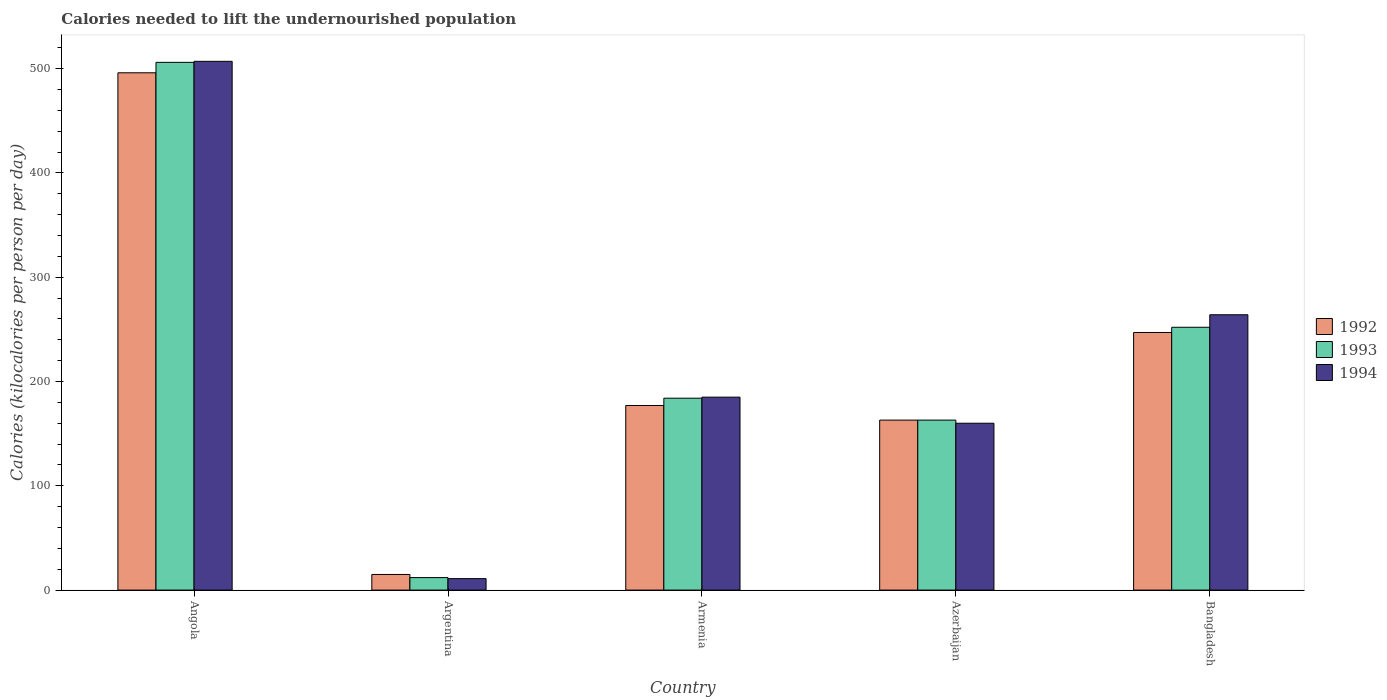How many different coloured bars are there?
Make the answer very short. 3. How many groups of bars are there?
Keep it short and to the point. 5. Are the number of bars per tick equal to the number of legend labels?
Your answer should be very brief. Yes. What is the label of the 1st group of bars from the left?
Make the answer very short. Angola. What is the total calories needed to lift the undernourished population in 1992 in Armenia?
Provide a short and direct response. 177. Across all countries, what is the maximum total calories needed to lift the undernourished population in 1992?
Provide a succinct answer. 496. In which country was the total calories needed to lift the undernourished population in 1992 maximum?
Provide a succinct answer. Angola. What is the total total calories needed to lift the undernourished population in 1994 in the graph?
Your answer should be compact. 1127. What is the difference between the total calories needed to lift the undernourished population in 1994 in Angola and that in Azerbaijan?
Give a very brief answer. 347. What is the difference between the total calories needed to lift the undernourished population in 1992 in Argentina and the total calories needed to lift the undernourished population in 1993 in Azerbaijan?
Your answer should be very brief. -148. What is the average total calories needed to lift the undernourished population in 1992 per country?
Your response must be concise. 219.6. In how many countries, is the total calories needed to lift the undernourished population in 1993 greater than 180 kilocalories?
Keep it short and to the point. 3. What is the ratio of the total calories needed to lift the undernourished population in 1993 in Armenia to that in Azerbaijan?
Make the answer very short. 1.13. What is the difference between the highest and the second highest total calories needed to lift the undernourished population in 1993?
Your answer should be compact. -322. What is the difference between the highest and the lowest total calories needed to lift the undernourished population in 1993?
Make the answer very short. 494. In how many countries, is the total calories needed to lift the undernourished population in 1994 greater than the average total calories needed to lift the undernourished population in 1994 taken over all countries?
Your response must be concise. 2. Is the sum of the total calories needed to lift the undernourished population in 1994 in Argentina and Azerbaijan greater than the maximum total calories needed to lift the undernourished population in 1993 across all countries?
Your answer should be compact. No. Is it the case that in every country, the sum of the total calories needed to lift the undernourished population in 1994 and total calories needed to lift the undernourished population in 1992 is greater than the total calories needed to lift the undernourished population in 1993?
Your answer should be very brief. Yes. How many countries are there in the graph?
Provide a succinct answer. 5. What is the difference between two consecutive major ticks on the Y-axis?
Your answer should be very brief. 100. Are the values on the major ticks of Y-axis written in scientific E-notation?
Your answer should be very brief. No. Does the graph contain any zero values?
Keep it short and to the point. No. Does the graph contain grids?
Offer a very short reply. No. Where does the legend appear in the graph?
Provide a succinct answer. Center right. What is the title of the graph?
Give a very brief answer. Calories needed to lift the undernourished population. Does "2014" appear as one of the legend labels in the graph?
Your answer should be compact. No. What is the label or title of the Y-axis?
Give a very brief answer. Calories (kilocalories per person per day). What is the Calories (kilocalories per person per day) of 1992 in Angola?
Ensure brevity in your answer.  496. What is the Calories (kilocalories per person per day) in 1993 in Angola?
Provide a succinct answer. 506. What is the Calories (kilocalories per person per day) in 1994 in Angola?
Your response must be concise. 507. What is the Calories (kilocalories per person per day) of 1992 in Argentina?
Make the answer very short. 15. What is the Calories (kilocalories per person per day) in 1992 in Armenia?
Your answer should be compact. 177. What is the Calories (kilocalories per person per day) of 1993 in Armenia?
Your answer should be compact. 184. What is the Calories (kilocalories per person per day) of 1994 in Armenia?
Make the answer very short. 185. What is the Calories (kilocalories per person per day) of 1992 in Azerbaijan?
Ensure brevity in your answer.  163. What is the Calories (kilocalories per person per day) in 1993 in Azerbaijan?
Your answer should be very brief. 163. What is the Calories (kilocalories per person per day) of 1994 in Azerbaijan?
Offer a very short reply. 160. What is the Calories (kilocalories per person per day) in 1992 in Bangladesh?
Your response must be concise. 247. What is the Calories (kilocalories per person per day) of 1993 in Bangladesh?
Offer a terse response. 252. What is the Calories (kilocalories per person per day) of 1994 in Bangladesh?
Ensure brevity in your answer.  264. Across all countries, what is the maximum Calories (kilocalories per person per day) in 1992?
Give a very brief answer. 496. Across all countries, what is the maximum Calories (kilocalories per person per day) of 1993?
Keep it short and to the point. 506. Across all countries, what is the maximum Calories (kilocalories per person per day) in 1994?
Offer a terse response. 507. What is the total Calories (kilocalories per person per day) of 1992 in the graph?
Provide a short and direct response. 1098. What is the total Calories (kilocalories per person per day) in 1993 in the graph?
Offer a terse response. 1117. What is the total Calories (kilocalories per person per day) in 1994 in the graph?
Your answer should be very brief. 1127. What is the difference between the Calories (kilocalories per person per day) of 1992 in Angola and that in Argentina?
Your answer should be compact. 481. What is the difference between the Calories (kilocalories per person per day) of 1993 in Angola and that in Argentina?
Ensure brevity in your answer.  494. What is the difference between the Calories (kilocalories per person per day) of 1994 in Angola and that in Argentina?
Your answer should be compact. 496. What is the difference between the Calories (kilocalories per person per day) in 1992 in Angola and that in Armenia?
Offer a very short reply. 319. What is the difference between the Calories (kilocalories per person per day) in 1993 in Angola and that in Armenia?
Ensure brevity in your answer.  322. What is the difference between the Calories (kilocalories per person per day) of 1994 in Angola and that in Armenia?
Give a very brief answer. 322. What is the difference between the Calories (kilocalories per person per day) in 1992 in Angola and that in Azerbaijan?
Make the answer very short. 333. What is the difference between the Calories (kilocalories per person per day) in 1993 in Angola and that in Azerbaijan?
Ensure brevity in your answer.  343. What is the difference between the Calories (kilocalories per person per day) in 1994 in Angola and that in Azerbaijan?
Your answer should be compact. 347. What is the difference between the Calories (kilocalories per person per day) in 1992 in Angola and that in Bangladesh?
Your answer should be compact. 249. What is the difference between the Calories (kilocalories per person per day) of 1993 in Angola and that in Bangladesh?
Offer a terse response. 254. What is the difference between the Calories (kilocalories per person per day) of 1994 in Angola and that in Bangladesh?
Give a very brief answer. 243. What is the difference between the Calories (kilocalories per person per day) in 1992 in Argentina and that in Armenia?
Your answer should be very brief. -162. What is the difference between the Calories (kilocalories per person per day) in 1993 in Argentina and that in Armenia?
Ensure brevity in your answer.  -172. What is the difference between the Calories (kilocalories per person per day) of 1994 in Argentina and that in Armenia?
Provide a succinct answer. -174. What is the difference between the Calories (kilocalories per person per day) in 1992 in Argentina and that in Azerbaijan?
Provide a succinct answer. -148. What is the difference between the Calories (kilocalories per person per day) in 1993 in Argentina and that in Azerbaijan?
Your answer should be very brief. -151. What is the difference between the Calories (kilocalories per person per day) of 1994 in Argentina and that in Azerbaijan?
Give a very brief answer. -149. What is the difference between the Calories (kilocalories per person per day) of 1992 in Argentina and that in Bangladesh?
Make the answer very short. -232. What is the difference between the Calories (kilocalories per person per day) in 1993 in Argentina and that in Bangladesh?
Ensure brevity in your answer.  -240. What is the difference between the Calories (kilocalories per person per day) in 1994 in Argentina and that in Bangladesh?
Offer a terse response. -253. What is the difference between the Calories (kilocalories per person per day) in 1992 in Armenia and that in Azerbaijan?
Your response must be concise. 14. What is the difference between the Calories (kilocalories per person per day) of 1992 in Armenia and that in Bangladesh?
Keep it short and to the point. -70. What is the difference between the Calories (kilocalories per person per day) in 1993 in Armenia and that in Bangladesh?
Make the answer very short. -68. What is the difference between the Calories (kilocalories per person per day) in 1994 in Armenia and that in Bangladesh?
Your answer should be compact. -79. What is the difference between the Calories (kilocalories per person per day) in 1992 in Azerbaijan and that in Bangladesh?
Make the answer very short. -84. What is the difference between the Calories (kilocalories per person per day) in 1993 in Azerbaijan and that in Bangladesh?
Your answer should be very brief. -89. What is the difference between the Calories (kilocalories per person per day) of 1994 in Azerbaijan and that in Bangladesh?
Your answer should be very brief. -104. What is the difference between the Calories (kilocalories per person per day) of 1992 in Angola and the Calories (kilocalories per person per day) of 1993 in Argentina?
Make the answer very short. 484. What is the difference between the Calories (kilocalories per person per day) in 1992 in Angola and the Calories (kilocalories per person per day) in 1994 in Argentina?
Your answer should be very brief. 485. What is the difference between the Calories (kilocalories per person per day) of 1993 in Angola and the Calories (kilocalories per person per day) of 1994 in Argentina?
Provide a succinct answer. 495. What is the difference between the Calories (kilocalories per person per day) in 1992 in Angola and the Calories (kilocalories per person per day) in 1993 in Armenia?
Make the answer very short. 312. What is the difference between the Calories (kilocalories per person per day) in 1992 in Angola and the Calories (kilocalories per person per day) in 1994 in Armenia?
Offer a terse response. 311. What is the difference between the Calories (kilocalories per person per day) of 1993 in Angola and the Calories (kilocalories per person per day) of 1994 in Armenia?
Provide a short and direct response. 321. What is the difference between the Calories (kilocalories per person per day) in 1992 in Angola and the Calories (kilocalories per person per day) in 1993 in Azerbaijan?
Offer a very short reply. 333. What is the difference between the Calories (kilocalories per person per day) of 1992 in Angola and the Calories (kilocalories per person per day) of 1994 in Azerbaijan?
Give a very brief answer. 336. What is the difference between the Calories (kilocalories per person per day) of 1993 in Angola and the Calories (kilocalories per person per day) of 1994 in Azerbaijan?
Keep it short and to the point. 346. What is the difference between the Calories (kilocalories per person per day) in 1992 in Angola and the Calories (kilocalories per person per day) in 1993 in Bangladesh?
Offer a very short reply. 244. What is the difference between the Calories (kilocalories per person per day) in 1992 in Angola and the Calories (kilocalories per person per day) in 1994 in Bangladesh?
Provide a succinct answer. 232. What is the difference between the Calories (kilocalories per person per day) of 1993 in Angola and the Calories (kilocalories per person per day) of 1994 in Bangladesh?
Make the answer very short. 242. What is the difference between the Calories (kilocalories per person per day) of 1992 in Argentina and the Calories (kilocalories per person per day) of 1993 in Armenia?
Provide a succinct answer. -169. What is the difference between the Calories (kilocalories per person per day) of 1992 in Argentina and the Calories (kilocalories per person per day) of 1994 in Armenia?
Offer a very short reply. -170. What is the difference between the Calories (kilocalories per person per day) of 1993 in Argentina and the Calories (kilocalories per person per day) of 1994 in Armenia?
Your answer should be very brief. -173. What is the difference between the Calories (kilocalories per person per day) in 1992 in Argentina and the Calories (kilocalories per person per day) in 1993 in Azerbaijan?
Your answer should be very brief. -148. What is the difference between the Calories (kilocalories per person per day) of 1992 in Argentina and the Calories (kilocalories per person per day) of 1994 in Azerbaijan?
Ensure brevity in your answer.  -145. What is the difference between the Calories (kilocalories per person per day) of 1993 in Argentina and the Calories (kilocalories per person per day) of 1994 in Azerbaijan?
Your answer should be compact. -148. What is the difference between the Calories (kilocalories per person per day) in 1992 in Argentina and the Calories (kilocalories per person per day) in 1993 in Bangladesh?
Make the answer very short. -237. What is the difference between the Calories (kilocalories per person per day) of 1992 in Argentina and the Calories (kilocalories per person per day) of 1994 in Bangladesh?
Ensure brevity in your answer.  -249. What is the difference between the Calories (kilocalories per person per day) in 1993 in Argentina and the Calories (kilocalories per person per day) in 1994 in Bangladesh?
Keep it short and to the point. -252. What is the difference between the Calories (kilocalories per person per day) in 1992 in Armenia and the Calories (kilocalories per person per day) in 1993 in Bangladesh?
Make the answer very short. -75. What is the difference between the Calories (kilocalories per person per day) in 1992 in Armenia and the Calories (kilocalories per person per day) in 1994 in Bangladesh?
Offer a very short reply. -87. What is the difference between the Calories (kilocalories per person per day) of 1993 in Armenia and the Calories (kilocalories per person per day) of 1994 in Bangladesh?
Give a very brief answer. -80. What is the difference between the Calories (kilocalories per person per day) of 1992 in Azerbaijan and the Calories (kilocalories per person per day) of 1993 in Bangladesh?
Your answer should be compact. -89. What is the difference between the Calories (kilocalories per person per day) of 1992 in Azerbaijan and the Calories (kilocalories per person per day) of 1994 in Bangladesh?
Ensure brevity in your answer.  -101. What is the difference between the Calories (kilocalories per person per day) in 1993 in Azerbaijan and the Calories (kilocalories per person per day) in 1994 in Bangladesh?
Your answer should be very brief. -101. What is the average Calories (kilocalories per person per day) of 1992 per country?
Make the answer very short. 219.6. What is the average Calories (kilocalories per person per day) in 1993 per country?
Give a very brief answer. 223.4. What is the average Calories (kilocalories per person per day) in 1994 per country?
Your answer should be compact. 225.4. What is the difference between the Calories (kilocalories per person per day) in 1992 and Calories (kilocalories per person per day) in 1994 in Argentina?
Ensure brevity in your answer.  4. What is the difference between the Calories (kilocalories per person per day) in 1992 and Calories (kilocalories per person per day) in 1993 in Armenia?
Your answer should be compact. -7. What is the difference between the Calories (kilocalories per person per day) of 1992 and Calories (kilocalories per person per day) of 1994 in Armenia?
Ensure brevity in your answer.  -8. What is the difference between the Calories (kilocalories per person per day) in 1993 and Calories (kilocalories per person per day) in 1994 in Armenia?
Provide a succinct answer. -1. What is the difference between the Calories (kilocalories per person per day) of 1993 and Calories (kilocalories per person per day) of 1994 in Azerbaijan?
Offer a very short reply. 3. What is the ratio of the Calories (kilocalories per person per day) in 1992 in Angola to that in Argentina?
Your response must be concise. 33.07. What is the ratio of the Calories (kilocalories per person per day) in 1993 in Angola to that in Argentina?
Provide a succinct answer. 42.17. What is the ratio of the Calories (kilocalories per person per day) of 1994 in Angola to that in Argentina?
Your answer should be very brief. 46.09. What is the ratio of the Calories (kilocalories per person per day) of 1992 in Angola to that in Armenia?
Offer a very short reply. 2.8. What is the ratio of the Calories (kilocalories per person per day) of 1993 in Angola to that in Armenia?
Offer a very short reply. 2.75. What is the ratio of the Calories (kilocalories per person per day) of 1994 in Angola to that in Armenia?
Offer a terse response. 2.74. What is the ratio of the Calories (kilocalories per person per day) of 1992 in Angola to that in Azerbaijan?
Ensure brevity in your answer.  3.04. What is the ratio of the Calories (kilocalories per person per day) in 1993 in Angola to that in Azerbaijan?
Offer a very short reply. 3.1. What is the ratio of the Calories (kilocalories per person per day) in 1994 in Angola to that in Azerbaijan?
Ensure brevity in your answer.  3.17. What is the ratio of the Calories (kilocalories per person per day) of 1992 in Angola to that in Bangladesh?
Make the answer very short. 2.01. What is the ratio of the Calories (kilocalories per person per day) of 1993 in Angola to that in Bangladesh?
Keep it short and to the point. 2.01. What is the ratio of the Calories (kilocalories per person per day) in 1994 in Angola to that in Bangladesh?
Your response must be concise. 1.92. What is the ratio of the Calories (kilocalories per person per day) of 1992 in Argentina to that in Armenia?
Give a very brief answer. 0.08. What is the ratio of the Calories (kilocalories per person per day) in 1993 in Argentina to that in Armenia?
Your response must be concise. 0.07. What is the ratio of the Calories (kilocalories per person per day) in 1994 in Argentina to that in Armenia?
Offer a terse response. 0.06. What is the ratio of the Calories (kilocalories per person per day) of 1992 in Argentina to that in Azerbaijan?
Ensure brevity in your answer.  0.09. What is the ratio of the Calories (kilocalories per person per day) of 1993 in Argentina to that in Azerbaijan?
Keep it short and to the point. 0.07. What is the ratio of the Calories (kilocalories per person per day) of 1994 in Argentina to that in Azerbaijan?
Keep it short and to the point. 0.07. What is the ratio of the Calories (kilocalories per person per day) in 1992 in Argentina to that in Bangladesh?
Ensure brevity in your answer.  0.06. What is the ratio of the Calories (kilocalories per person per day) of 1993 in Argentina to that in Bangladesh?
Your answer should be very brief. 0.05. What is the ratio of the Calories (kilocalories per person per day) of 1994 in Argentina to that in Bangladesh?
Provide a succinct answer. 0.04. What is the ratio of the Calories (kilocalories per person per day) of 1992 in Armenia to that in Azerbaijan?
Ensure brevity in your answer.  1.09. What is the ratio of the Calories (kilocalories per person per day) of 1993 in Armenia to that in Azerbaijan?
Offer a terse response. 1.13. What is the ratio of the Calories (kilocalories per person per day) of 1994 in Armenia to that in Azerbaijan?
Make the answer very short. 1.16. What is the ratio of the Calories (kilocalories per person per day) in 1992 in Armenia to that in Bangladesh?
Keep it short and to the point. 0.72. What is the ratio of the Calories (kilocalories per person per day) of 1993 in Armenia to that in Bangladesh?
Keep it short and to the point. 0.73. What is the ratio of the Calories (kilocalories per person per day) of 1994 in Armenia to that in Bangladesh?
Provide a short and direct response. 0.7. What is the ratio of the Calories (kilocalories per person per day) in 1992 in Azerbaijan to that in Bangladesh?
Your answer should be very brief. 0.66. What is the ratio of the Calories (kilocalories per person per day) of 1993 in Azerbaijan to that in Bangladesh?
Your response must be concise. 0.65. What is the ratio of the Calories (kilocalories per person per day) in 1994 in Azerbaijan to that in Bangladesh?
Give a very brief answer. 0.61. What is the difference between the highest and the second highest Calories (kilocalories per person per day) in 1992?
Give a very brief answer. 249. What is the difference between the highest and the second highest Calories (kilocalories per person per day) in 1993?
Your answer should be compact. 254. What is the difference between the highest and the second highest Calories (kilocalories per person per day) in 1994?
Your response must be concise. 243. What is the difference between the highest and the lowest Calories (kilocalories per person per day) of 1992?
Provide a short and direct response. 481. What is the difference between the highest and the lowest Calories (kilocalories per person per day) in 1993?
Your response must be concise. 494. What is the difference between the highest and the lowest Calories (kilocalories per person per day) in 1994?
Ensure brevity in your answer.  496. 